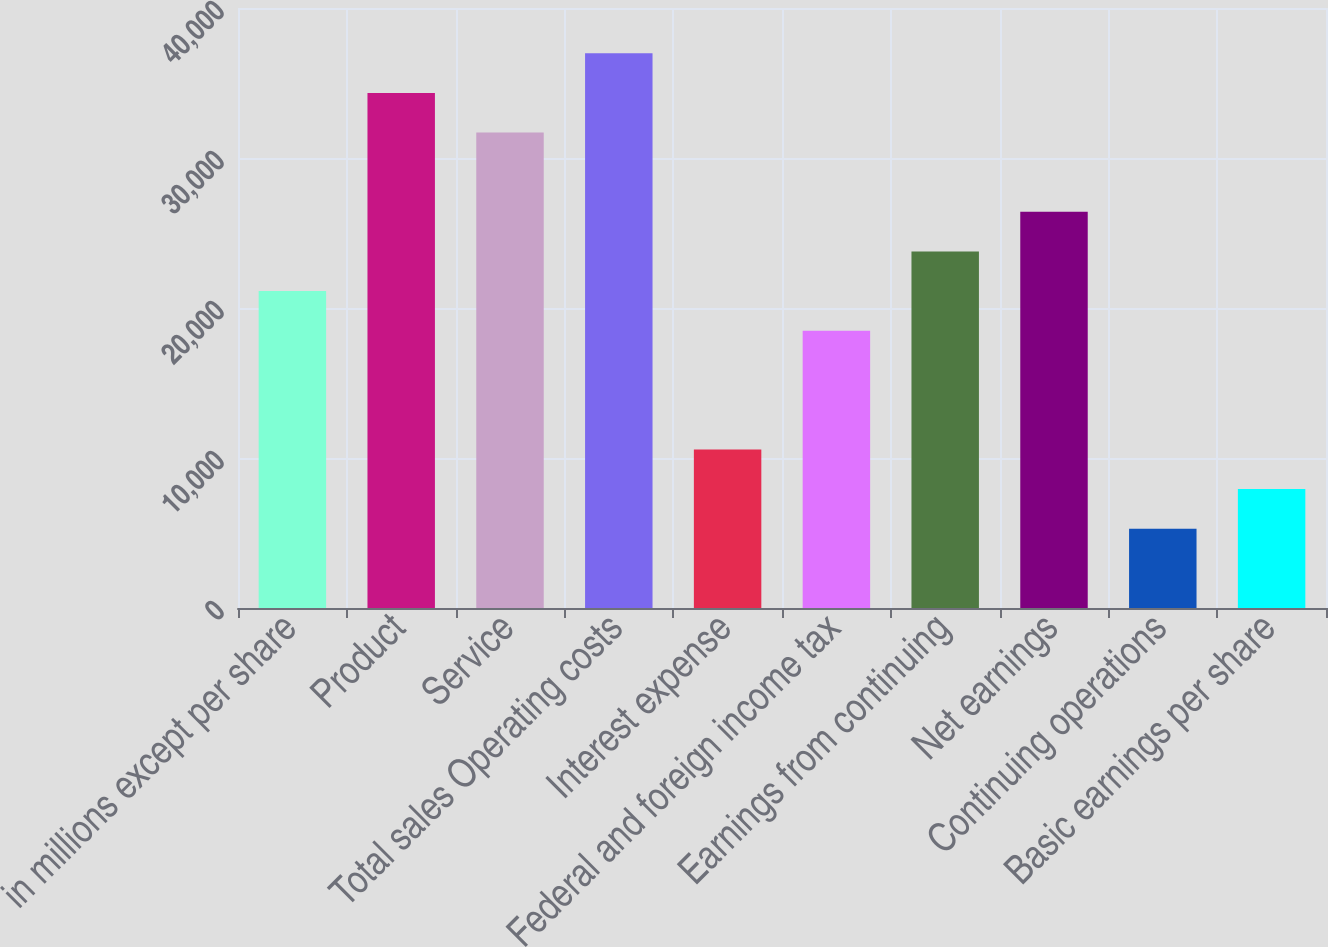<chart> <loc_0><loc_0><loc_500><loc_500><bar_chart><fcel>in millions except per share<fcel>Product<fcel>Service<fcel>Total sales Operating costs<fcel>Interest expense<fcel>Federal and foreign income tax<fcel>Earnings from continuing<fcel>Net earnings<fcel>Continuing operations<fcel>Basic earnings per share<nl><fcel>21130.4<fcel>34334.4<fcel>31693.6<fcel>36975.2<fcel>10567.2<fcel>18489.6<fcel>23771.2<fcel>26412<fcel>5285.6<fcel>7926.4<nl></chart> 